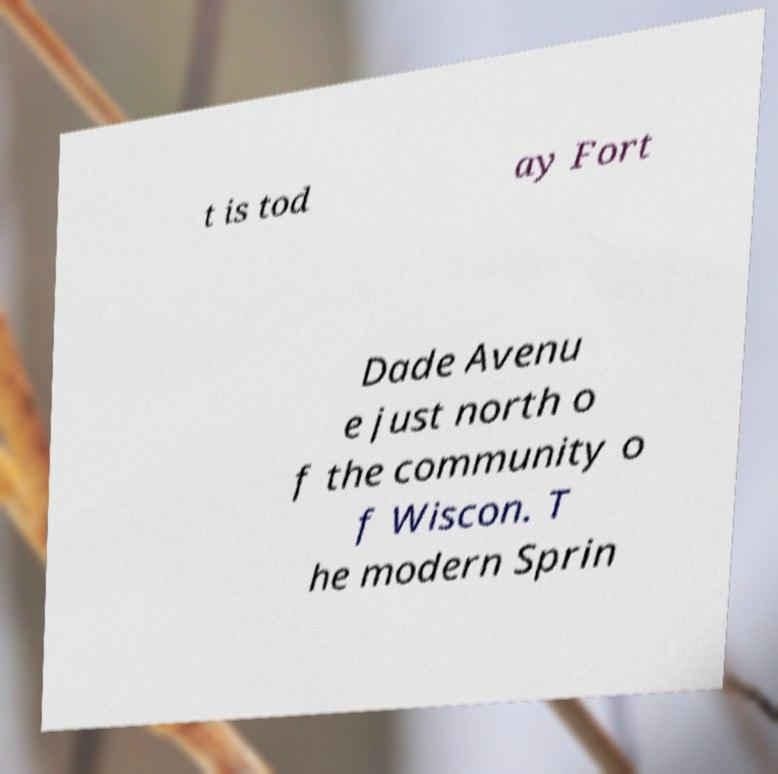Can you accurately transcribe the text from the provided image for me? t is tod ay Fort Dade Avenu e just north o f the community o f Wiscon. T he modern Sprin 